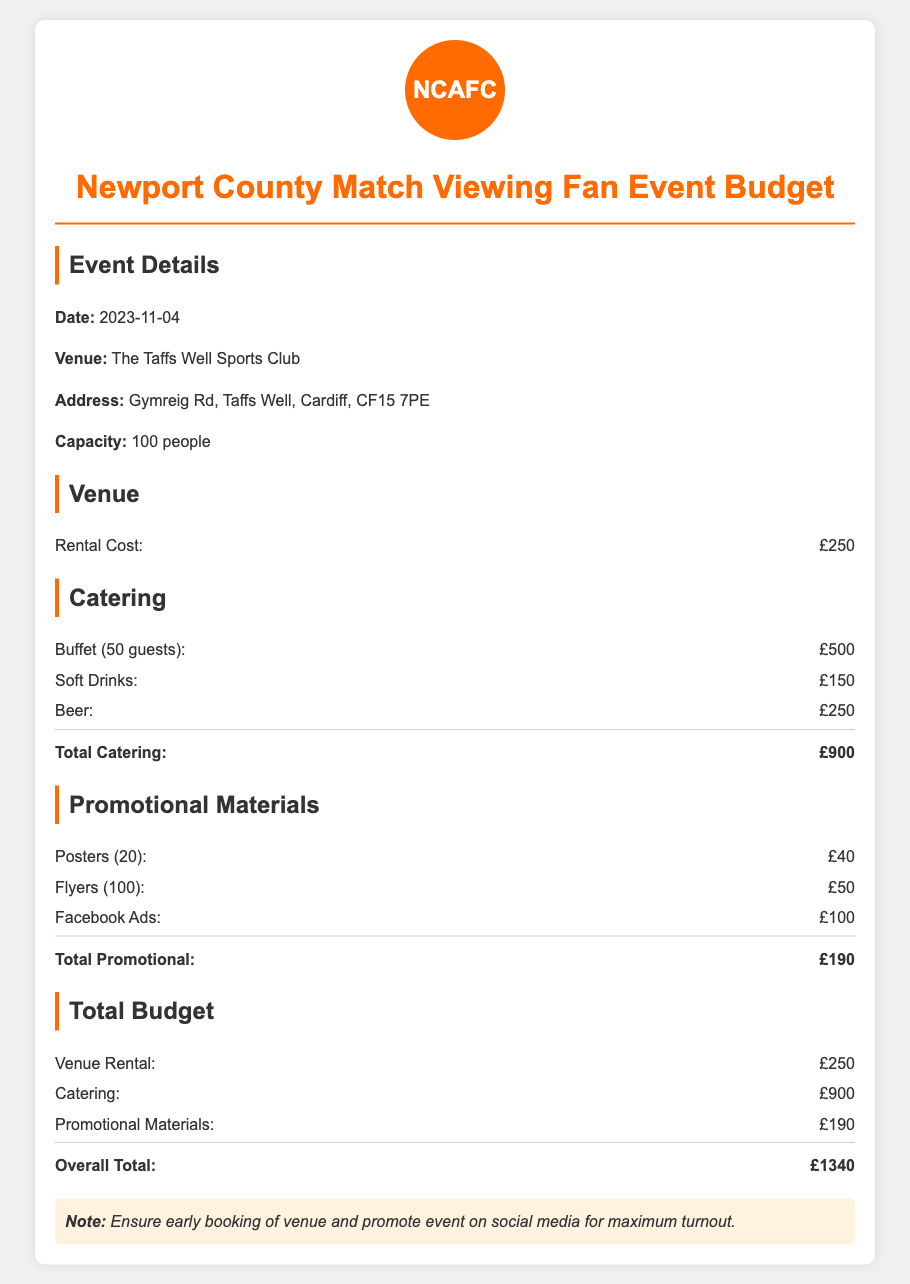What is the date of the event? The date of the event is explicitly stated in the document.
Answer: 2023-11-04 What is the venue for the event? The document clearly specifies the venue where the event will take place.
Answer: The Taffs Well Sports Club How much is the venue rental cost? The rental cost for the venue is provided in the budget section.
Answer: £250 What is the total cost for catering? The total catering cost is calculated by summing up the individual catering items listed.
Answer: £900 How many guests are the catering costs based on? The document specifies the number of guests for whom the catering is planned.
Answer: 50 guests What is the total budget for promotional materials? The total cost for promotional materials is detailed in the document.
Answer: £190 What is the overall total budget for the event? The overall total is the sum of all budget sections mentioned in the document.
Answer: £1340 What are the types of drinks included in the catering budget? The document lists the types of drinks that are part of the catering budget.
Answer: Soft Drinks and Beer What type of promotional materials are included? The document provides examples of the promotional materials being budgeted for.
Answer: Posters, Flyers, Facebook Ads What should be ensured for maximum turnout? The document notes an important consideration for the event's promotion.
Answer: Early booking of venue 